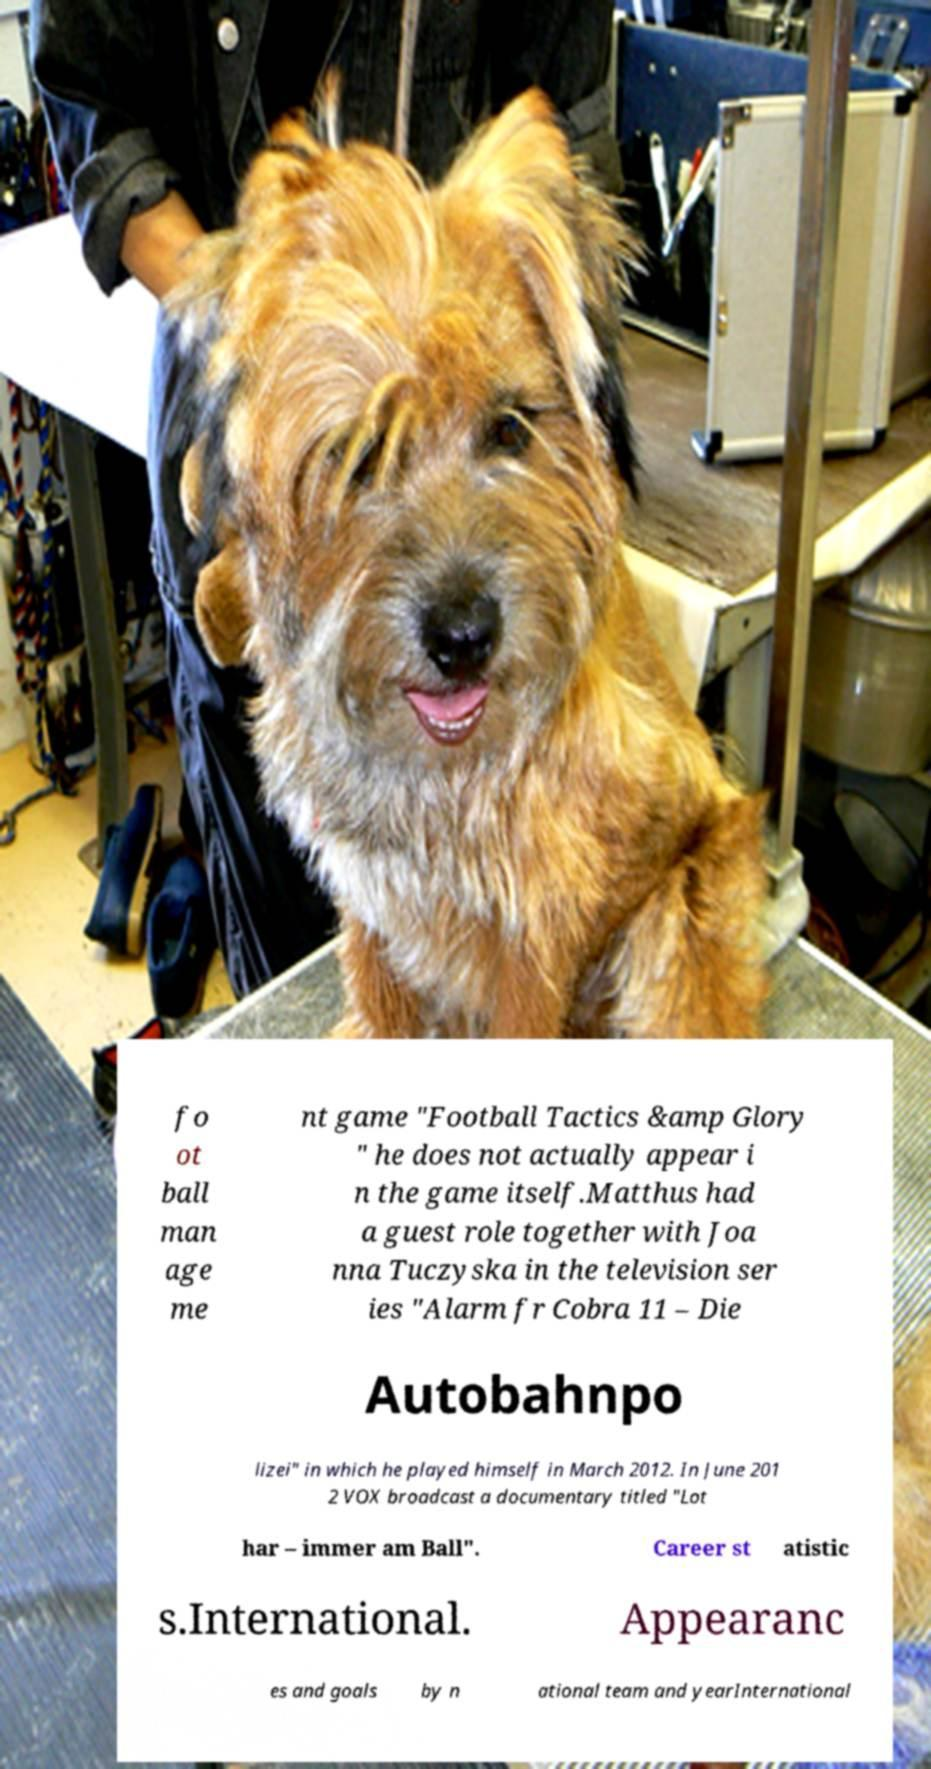Please read and relay the text visible in this image. What does it say? fo ot ball man age me nt game "Football Tactics &amp Glory " he does not actually appear i n the game itself.Matthus had a guest role together with Joa nna Tuczyska in the television ser ies "Alarm fr Cobra 11 – Die Autobahnpo lizei" in which he played himself in March 2012. In June 201 2 VOX broadcast a documentary titled "Lot har – immer am Ball". Career st atistic s.International. Appearanc es and goals by n ational team and yearInternational 